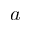Convert formula to latex. <formula><loc_0><loc_0><loc_500><loc_500>a</formula> 